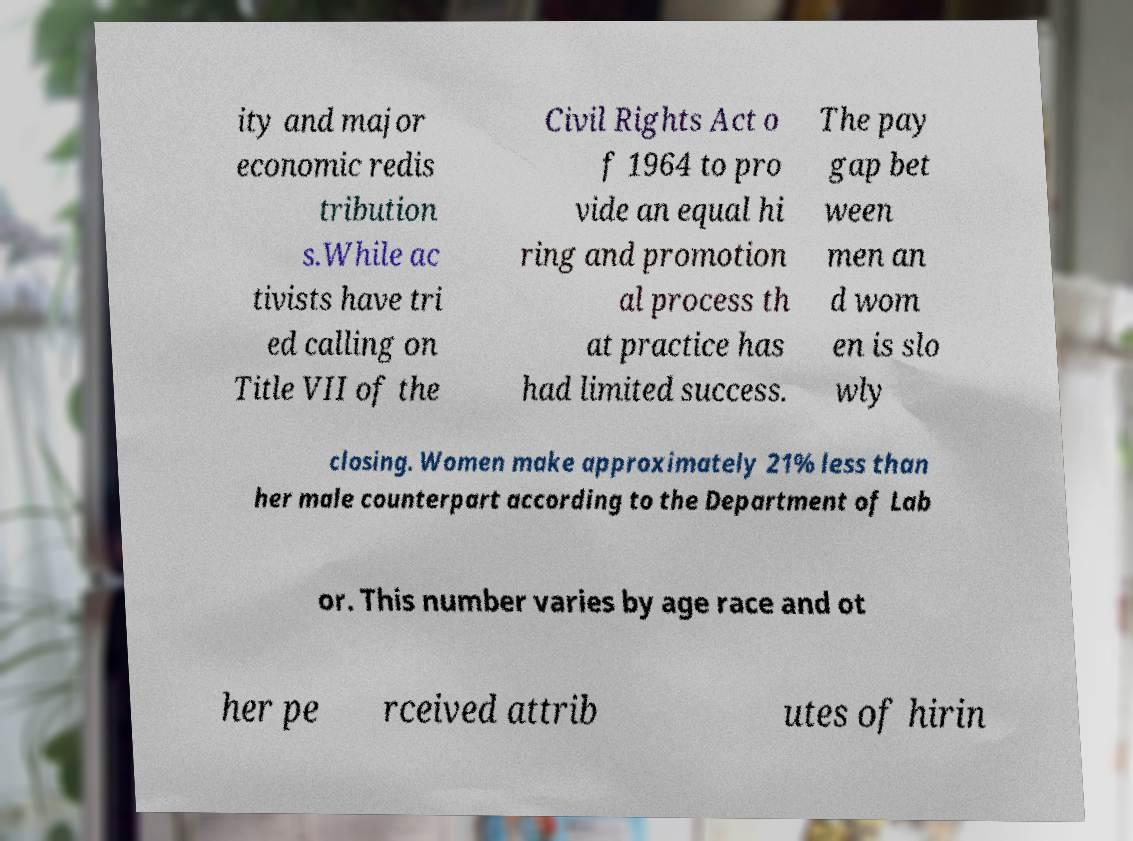There's text embedded in this image that I need extracted. Can you transcribe it verbatim? ity and major economic redis tribution s.While ac tivists have tri ed calling on Title VII of the Civil Rights Act o f 1964 to pro vide an equal hi ring and promotion al process th at practice has had limited success. The pay gap bet ween men an d wom en is slo wly closing. Women make approximately 21% less than her male counterpart according to the Department of Lab or. This number varies by age race and ot her pe rceived attrib utes of hirin 